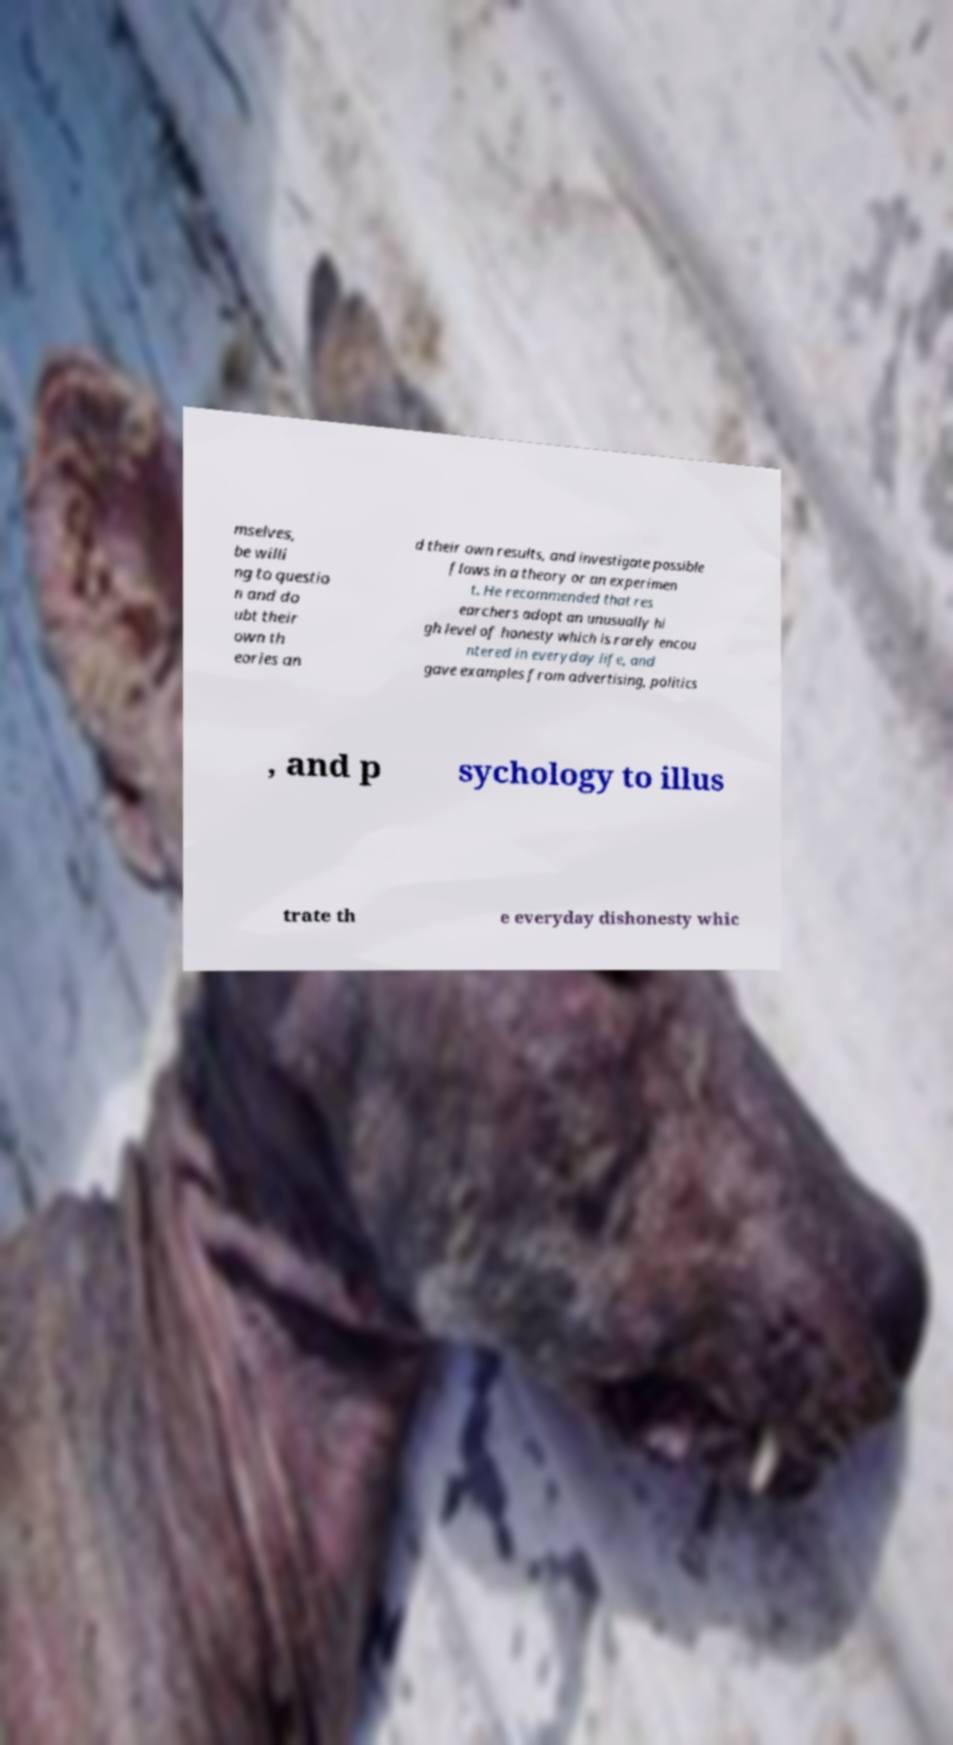There's text embedded in this image that I need extracted. Can you transcribe it verbatim? mselves, be willi ng to questio n and do ubt their own th eories an d their own results, and investigate possible flaws in a theory or an experimen t. He recommended that res earchers adopt an unusually hi gh level of honesty which is rarely encou ntered in everyday life, and gave examples from advertising, politics , and p sychology to illus trate th e everyday dishonesty whic 